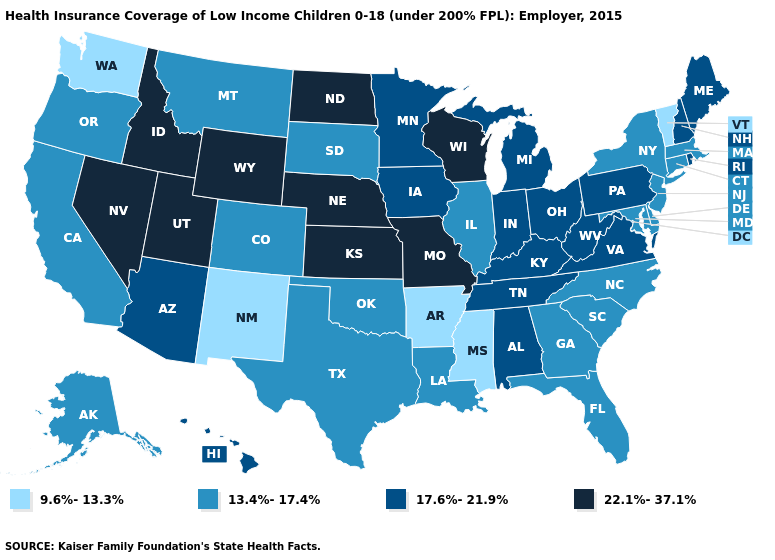How many symbols are there in the legend?
Write a very short answer. 4. Which states have the highest value in the USA?
Keep it brief. Idaho, Kansas, Missouri, Nebraska, Nevada, North Dakota, Utah, Wisconsin, Wyoming. Does Utah have a lower value than Wisconsin?
Answer briefly. No. Among the states that border Maine , which have the highest value?
Short answer required. New Hampshire. Name the states that have a value in the range 13.4%-17.4%?
Concise answer only. Alaska, California, Colorado, Connecticut, Delaware, Florida, Georgia, Illinois, Louisiana, Maryland, Massachusetts, Montana, New Jersey, New York, North Carolina, Oklahoma, Oregon, South Carolina, South Dakota, Texas. Does Mississippi have a higher value than South Dakota?
Give a very brief answer. No. Name the states that have a value in the range 17.6%-21.9%?
Keep it brief. Alabama, Arizona, Hawaii, Indiana, Iowa, Kentucky, Maine, Michigan, Minnesota, New Hampshire, Ohio, Pennsylvania, Rhode Island, Tennessee, Virginia, West Virginia. Name the states that have a value in the range 22.1%-37.1%?
Write a very short answer. Idaho, Kansas, Missouri, Nebraska, Nevada, North Dakota, Utah, Wisconsin, Wyoming. Among the states that border Minnesota , does Wisconsin have the highest value?
Short answer required. Yes. Name the states that have a value in the range 9.6%-13.3%?
Write a very short answer. Arkansas, Mississippi, New Mexico, Vermont, Washington. Name the states that have a value in the range 13.4%-17.4%?
Keep it brief. Alaska, California, Colorado, Connecticut, Delaware, Florida, Georgia, Illinois, Louisiana, Maryland, Massachusetts, Montana, New Jersey, New York, North Carolina, Oklahoma, Oregon, South Carolina, South Dakota, Texas. What is the value of Virginia?
Quick response, please. 17.6%-21.9%. Among the states that border Idaho , which have the highest value?
Give a very brief answer. Nevada, Utah, Wyoming. Which states hav the highest value in the South?
Short answer required. Alabama, Kentucky, Tennessee, Virginia, West Virginia. What is the highest value in states that border West Virginia?
Write a very short answer. 17.6%-21.9%. 